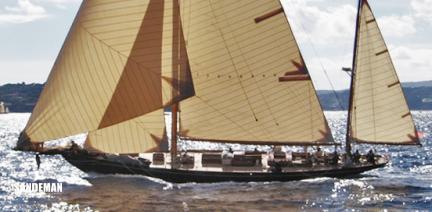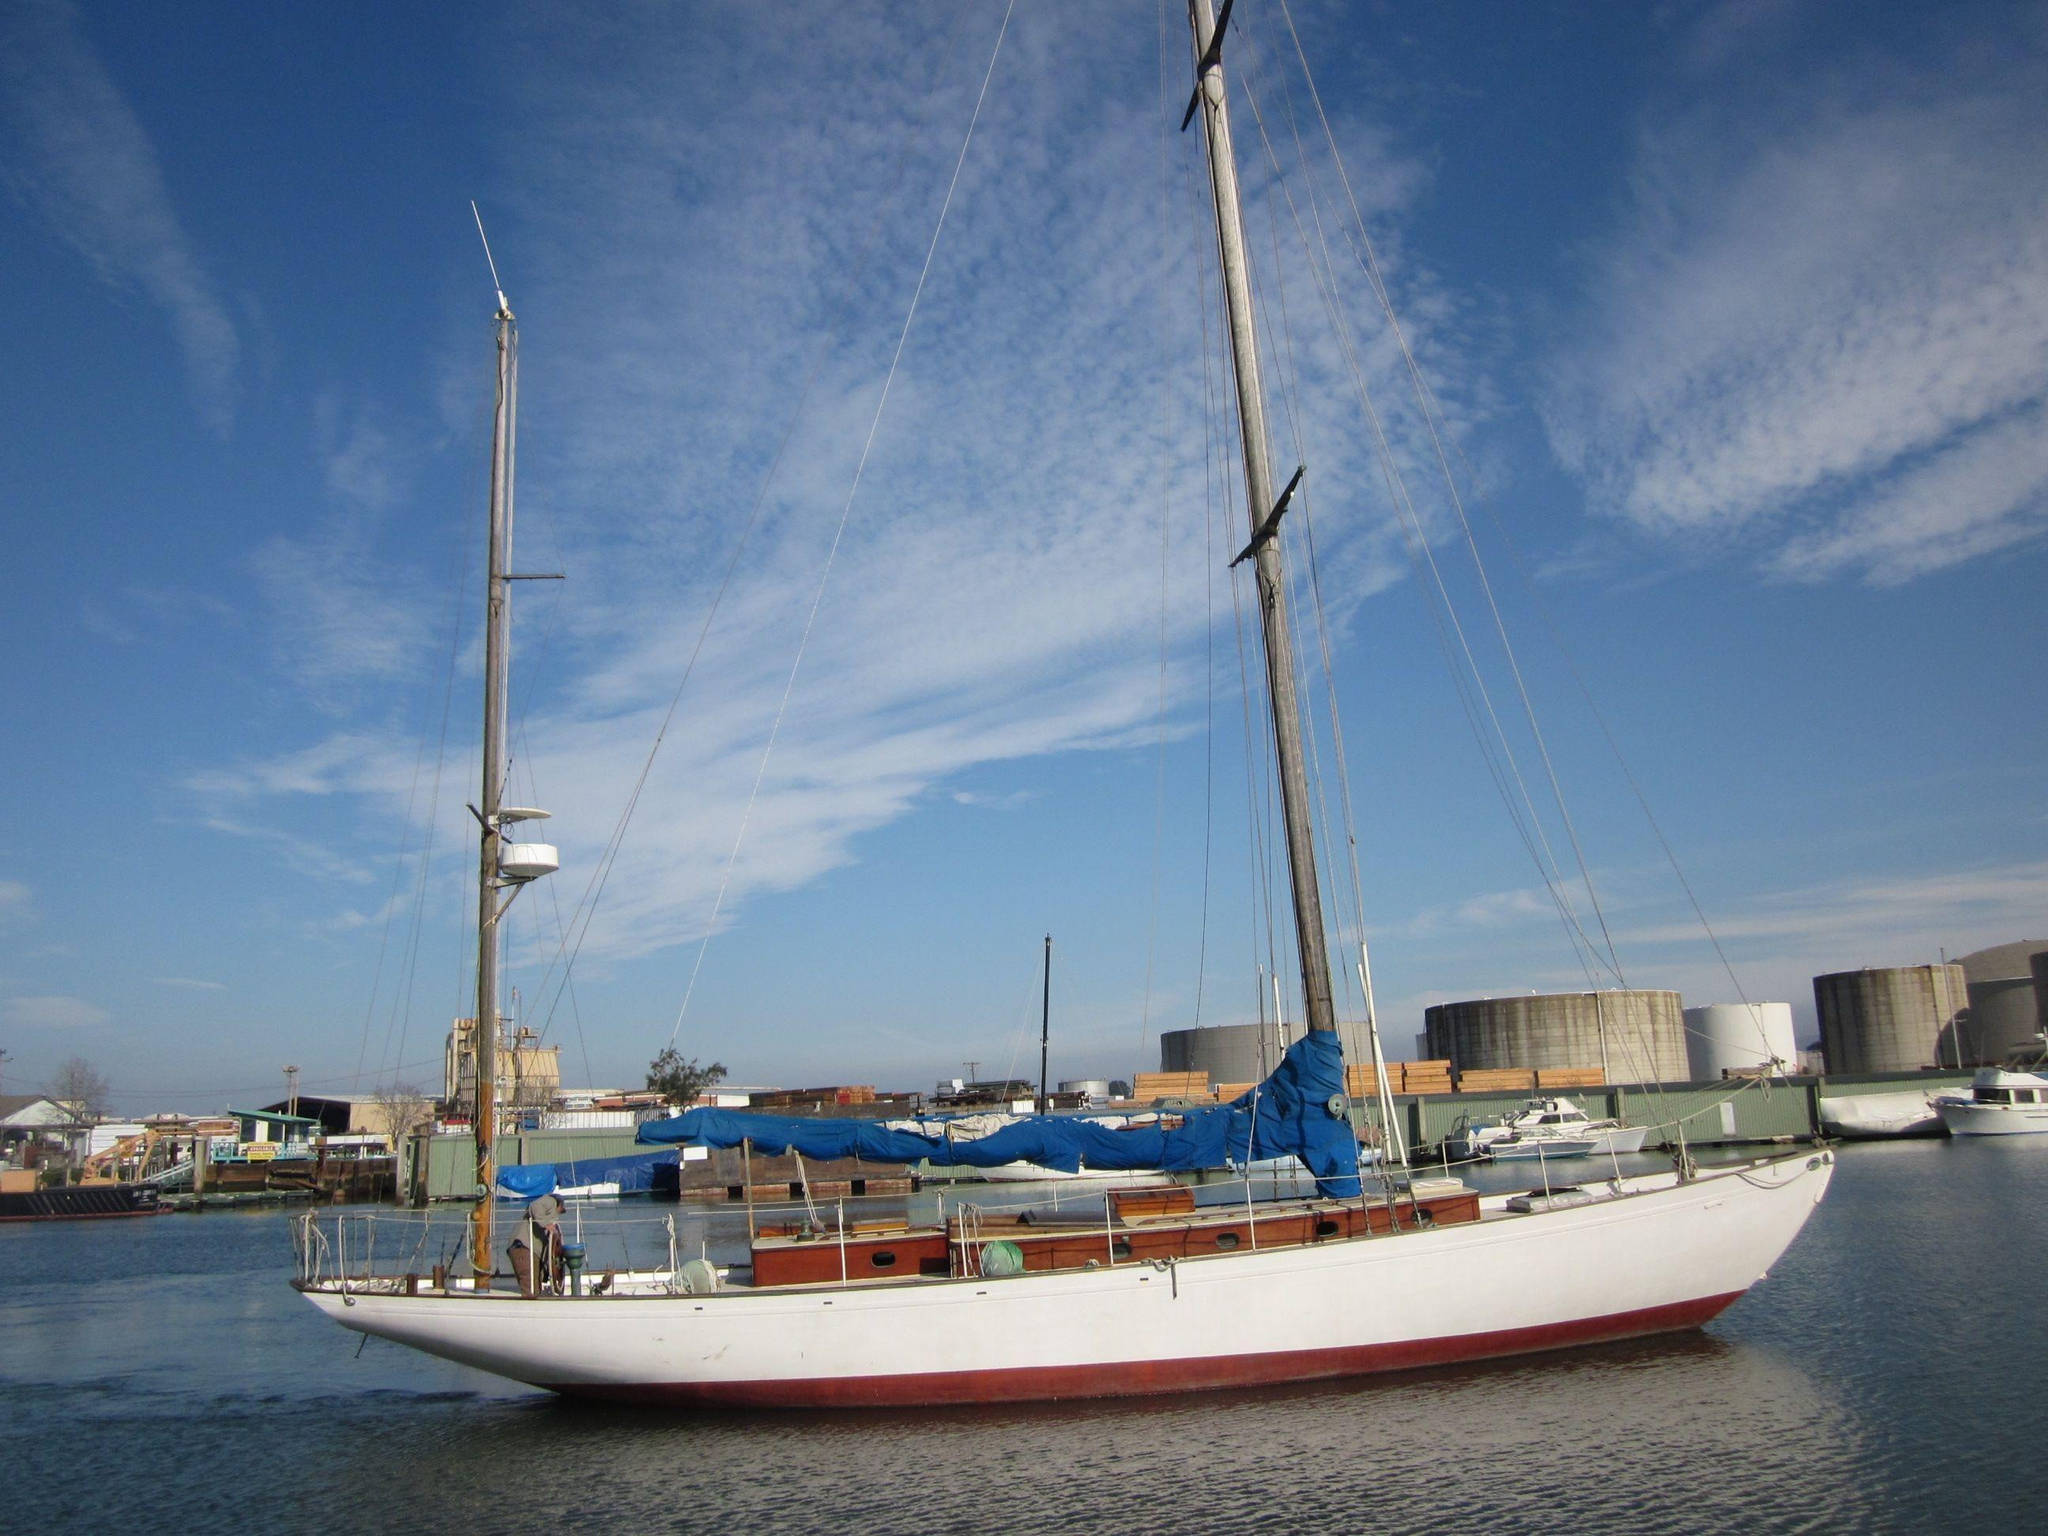The first image is the image on the left, the second image is the image on the right. Analyze the images presented: Is the assertion "The left and right image contains the same number of sailboats with there sails down." valid? Answer yes or no. No. The first image is the image on the left, the second image is the image on the right. Evaluate the accuracy of this statement regarding the images: "One sailboat is sitting on a platform on dry land, while a second sailboat is floating on water.". Is it true? Answer yes or no. No. 